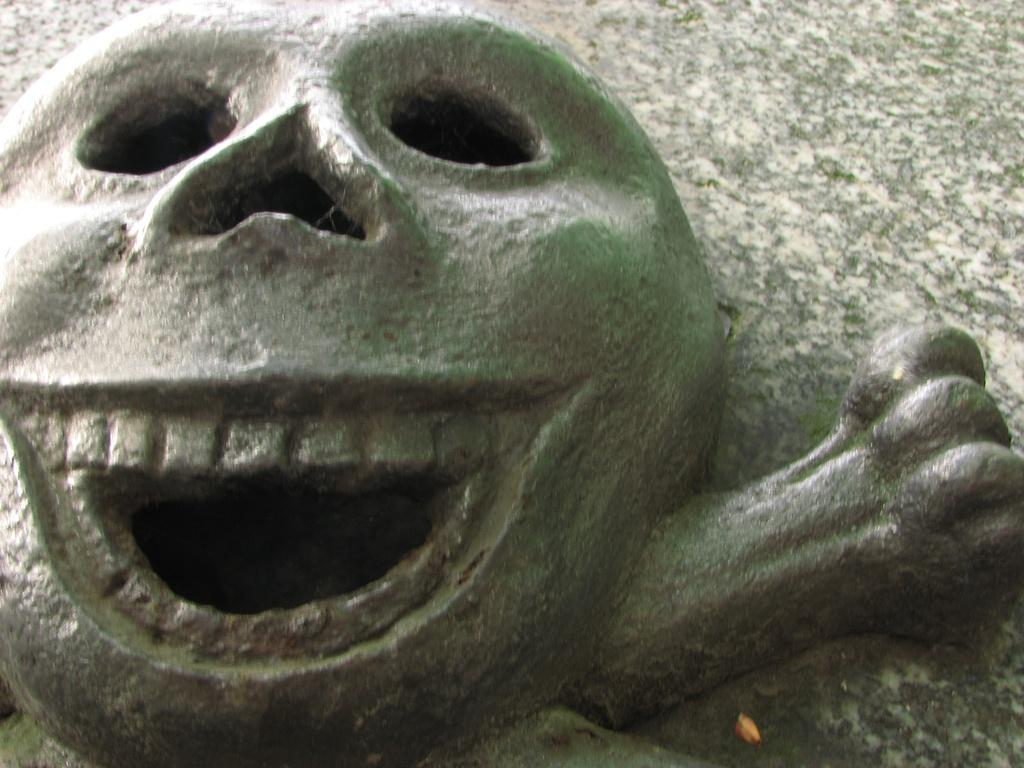What is the main subject in the image? There is a sculpture in the image. What type of club is the beetle holding in the image? There is no beetle or club present in the image; it only features a sculpture. What color is the orange in the image? There is no orange present in the image. 